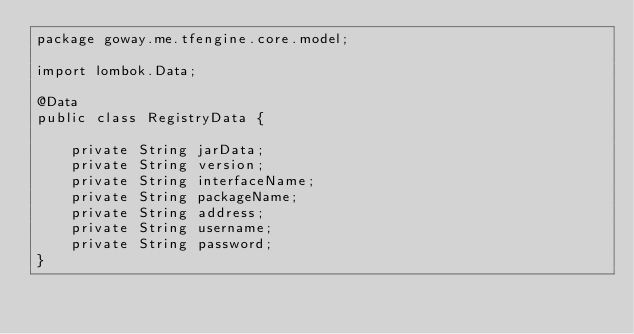<code> <loc_0><loc_0><loc_500><loc_500><_Java_>package goway.me.tfengine.core.model;

import lombok.Data;

@Data
public class RegistryData {

    private String jarData;
    private String version;
    private String interfaceName;
    private String packageName;
    private String address;
    private String username;
    private String password;
}
</code> 